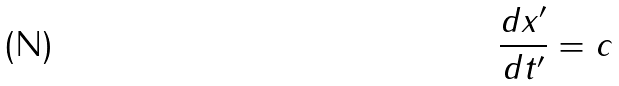Convert formula to latex. <formula><loc_0><loc_0><loc_500><loc_500>\frac { d x ^ { \prime } } { d t ^ { \prime } } = c</formula> 